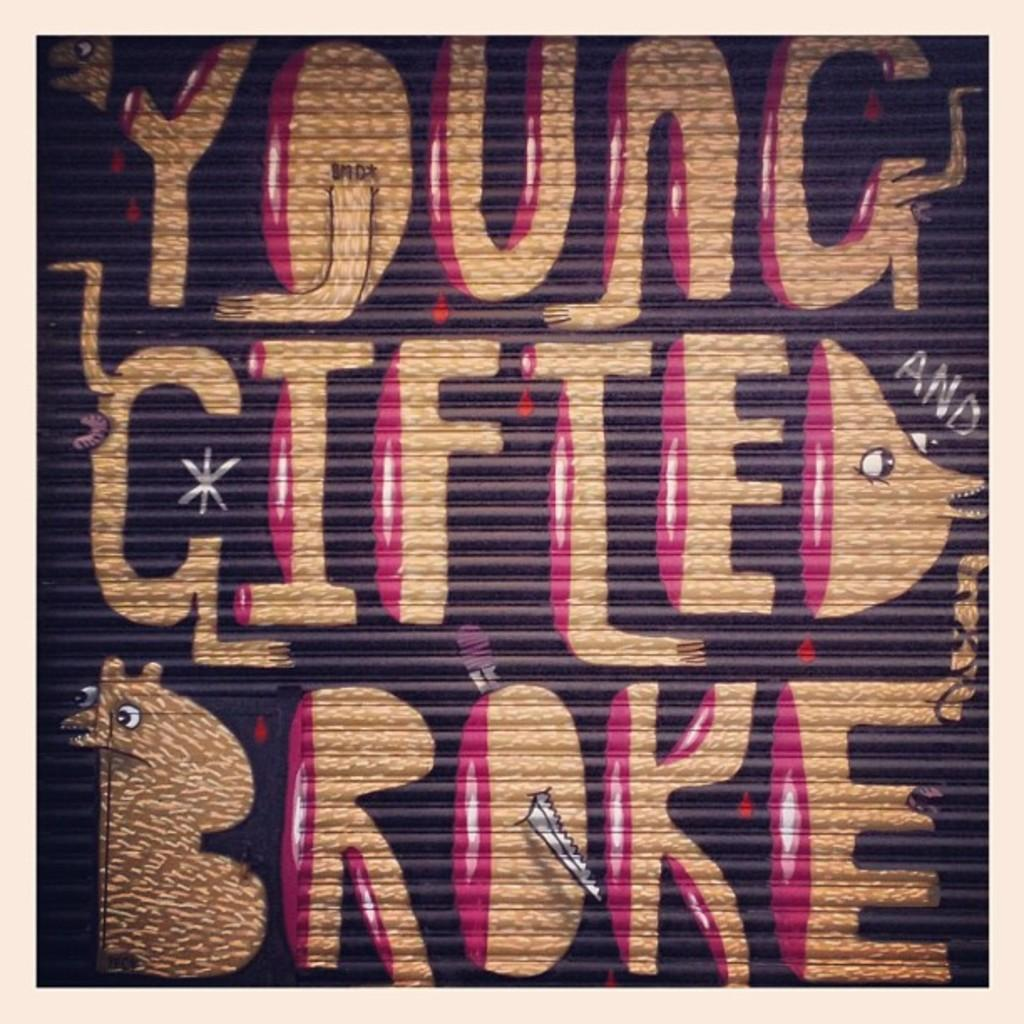<image>
Describe the image concisely. Wall art that says Young Gifted and Broke. 